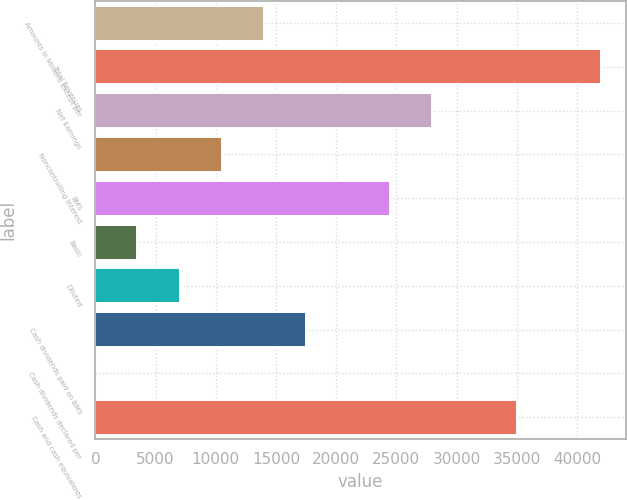<chart> <loc_0><loc_0><loc_500><loc_500><bar_chart><fcel>Amounts in Millions except per<fcel>Total Revenues<fcel>Net Earnings<fcel>Noncontrolling Interest<fcel>BMS<fcel>Basic<fcel>Diluted<fcel>Cash dividends paid on BMS<fcel>Cash dividends declared per<fcel>Cash and cash equivalents<nl><fcel>13995.4<fcel>41982.9<fcel>27989.1<fcel>10496.9<fcel>24490.7<fcel>3500.05<fcel>6998.49<fcel>17493.8<fcel>1.61<fcel>34986<nl></chart> 